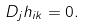Convert formula to latex. <formula><loc_0><loc_0><loc_500><loc_500>D _ { j } h _ { i k } = 0 .</formula> 